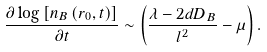Convert formula to latex. <formula><loc_0><loc_0><loc_500><loc_500>\frac { \partial \log \left [ n _ { B } \left ( r _ { 0 } , t \right ) \right ] } { \partial t } \sim \left ( \frac { \lambda - 2 d D _ { B } } { l ^ { 2 } } - \mu \right ) .</formula> 